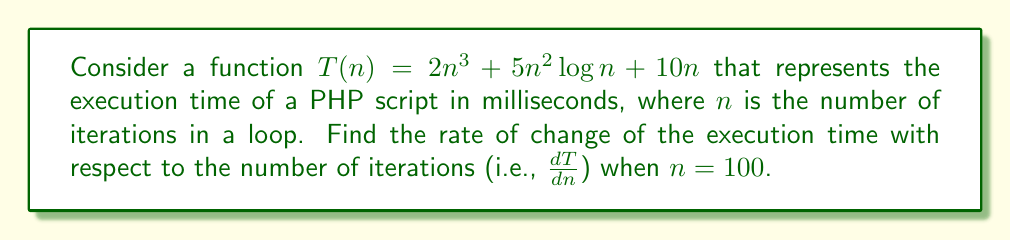What is the answer to this math problem? To find the rate of change of the execution time with respect to the number of iterations, we need to calculate the derivative of $T(n)$ and then evaluate it at $n = 100$. Let's break this down step-by-step:

1. First, let's differentiate each term of $T(n)$:

   a) For $2n^3$:
      $\frac{d}{dn}(2n^3) = 6n^2$

   b) For $5n^2 \log n$:
      Using the product rule and chain rule:
      $\frac{d}{dn}(5n^2 \log n) = 5 \cdot 2n \log n + 5n^2 \cdot \frac{1}{n} = 10n \log n + 5n$

   c) For $10n$:
      $\frac{d}{dn}(10n) = 10$

2. Now, let's combine these results:
   
   $\frac{dT}{dn} = 6n^2 + 10n \log n + 5n + 10$

3. Evaluate this at $n = 100$:
   
   $\frac{dT}{dn}|_{n=100} = 6(100)^2 + 10(100) \log 100 + 5(100) + 10$
   
   $= 60,000 + 1000 \log 100 + 500 + 10$
   
   $= 60,000 + 2000 + 500 + 10$ (since $\log 100 \approx 2$)
   
   $= 62,510$

Therefore, when $n = 100$, the rate of change of the execution time with respect to the number of iterations is approximately 62,510 milliseconds per iteration.
Answer: $62,510$ ms/iteration 